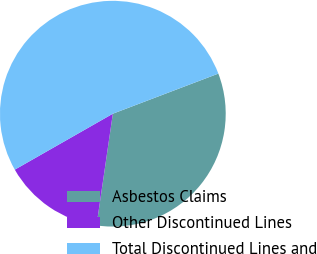Convert chart. <chart><loc_0><loc_0><loc_500><loc_500><pie_chart><fcel>Asbestos Claims<fcel>Other Discontinued Lines<fcel>Total Discontinued Lines and<nl><fcel>33.09%<fcel>14.44%<fcel>52.47%<nl></chart> 